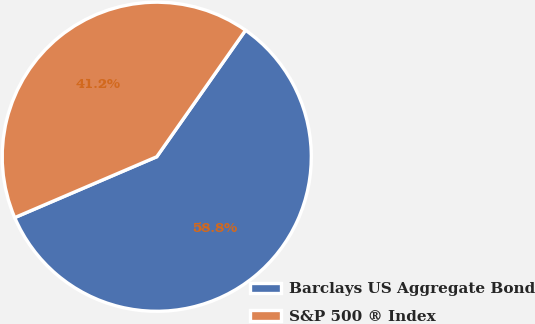Convert chart to OTSL. <chart><loc_0><loc_0><loc_500><loc_500><pie_chart><fcel>Barclays US Aggregate Bond<fcel>S&P 500 ® Index<nl><fcel>58.82%<fcel>41.18%<nl></chart> 